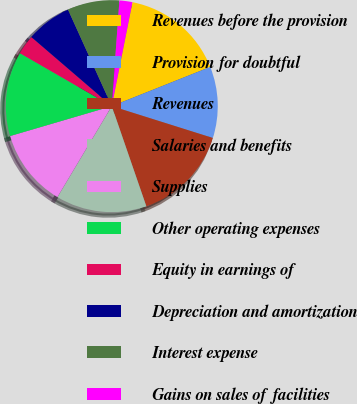<chart> <loc_0><loc_0><loc_500><loc_500><pie_chart><fcel>Revenues before the provision<fcel>Provision for doubtful<fcel>Revenues<fcel>Salaries and benefits<fcel>Supplies<fcel>Other operating expenses<fcel>Equity in earnings of<fcel>Depreciation and amortization<fcel>Interest expense<fcel>Gains on sales of facilities<nl><fcel>15.84%<fcel>10.89%<fcel>14.85%<fcel>13.86%<fcel>11.88%<fcel>12.87%<fcel>2.97%<fcel>6.93%<fcel>7.92%<fcel>1.98%<nl></chart> 